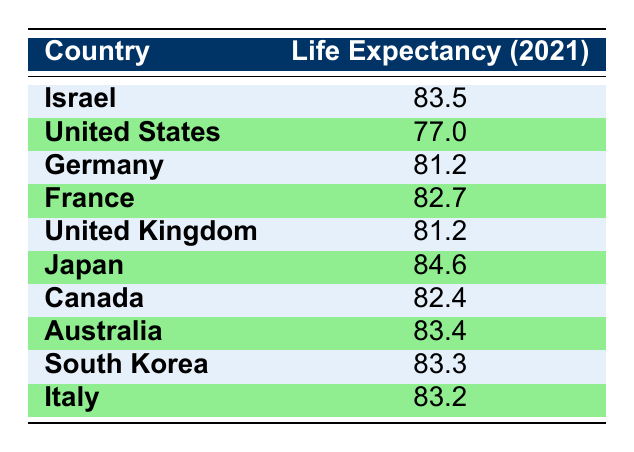What is the life expectancy in Israel for the year 2021? The table indicates that the life expectancy in Israel for the year 2021 is explicitly provided as 83.5.
Answer: 83.5 Which country has a lower life expectancy than Israel in 2021? By comparing the life expectancy values in the table, the United States (77.0), Germany (81.2), and the United Kingdom (81.2) all have lower life expectancy than Israel (83.5).
Answer: United States, Germany, United Kingdom What is the average life expectancy of OECD countries listed in the table? First, we note the life expectancy values of each country: (77.0, 81.2, 82.7, 81.2, 84.6, 82.4, 83.4, 83.3, 83.2). The total is 81.0 + 81.2 + 82.7 + 81.2 + 84.6 + 82.4 + 83.4 + 83.3 + 83.2 = 81.2. There are 9 countries, so the average is 81.2/9 = 82.3.
Answer: 82.3 Is the life expectancy in Japan higher than that of Israel? The table lists Japan with a life expectancy of 84.6, which is indeed higher than Israel's life expectancy of 83.5. Thus, the statement is true.
Answer: Yes What is the difference in life expectancy between the highest and lowest values in the table? The highest value is Japan (84.6) and the lowest is the United States (77.0). The difference is calculated as 84.6 - 77.0 = 7.6 years.
Answer: 7.6 Is it true that Canada has a life expectancy greater than Italy? The table shows Canada's life expectancy at 82.4 and Italy's at 83.2. Since 82.4 is less than 83.2, the statement is false.
Answer: No Which country has a life expectancy closest to that of Israel? Looking at the table, Australia has a life expectancy of 83.4, which is just 0.1 lower than Israel's 83.5. Therefore, Australia is the closest in terms of life expectancy.
Answer: Australia What is the median life expectancy of countries listed in the table? To find the median, we first arrange the life expectancy values in ascending order: 77.0, 81.2, 81.2, 82.4, 82.7, 83.2, 83.3, 83.4, 84.6. There are 9 values, so the median is the middle one: 82.7.
Answer: 82.7 Which countries have a life expectancy greater than 83? From the table, the countries with life expectancies greater than 83 are Japan (84.6), Australia (83.4), South Korea (83.3), Italy (83.2), and Israel (83.5).
Answer: Japan, Australia, South Korea, Italy, Israel 